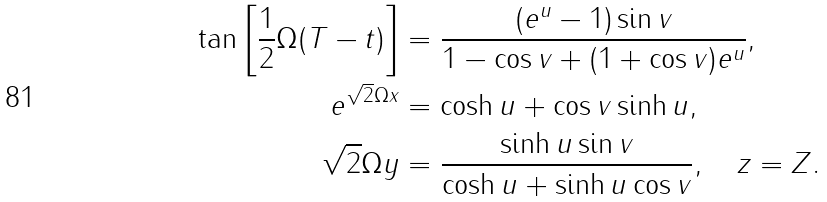<formula> <loc_0><loc_0><loc_500><loc_500>\tan \left [ \frac { 1 } { 2 } \Omega ( T - t ) \right ] & = \frac { ( e ^ { u } - 1 ) \sin v } { 1 - \cos v + ( 1 + \cos v ) e ^ { u } } , \\ e ^ { \sqrt { 2 } \Omega x } & = \cosh u + \cos v \sinh u , \\ \sqrt { 2 } \Omega y & = \frac { \sinh u \sin v } { \cosh u + \sinh u \cos v } , \quad z = Z .</formula> 